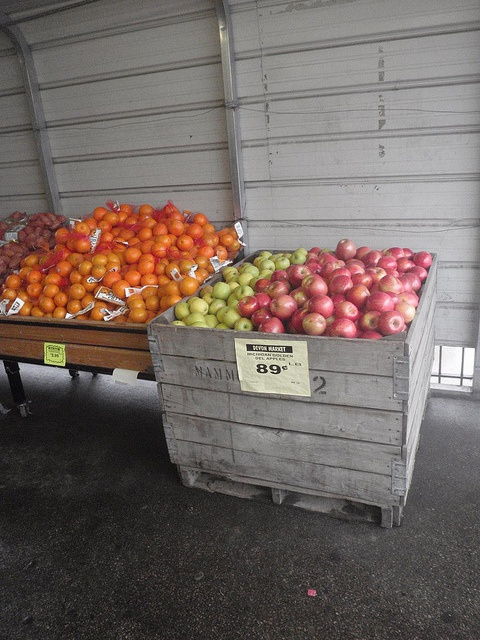Describe the objects in this image and their specific colors. I can see orange in black, brown, red, and maroon tones and apple in black, brown, lightpink, olive, and salmon tones in this image. 